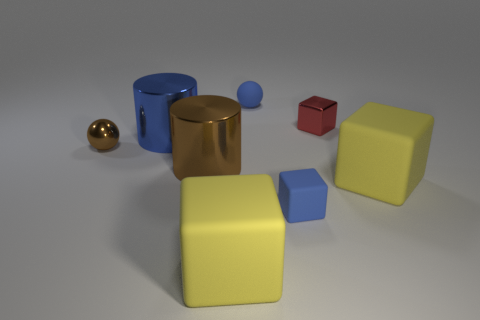Add 1 purple cubes. How many objects exist? 9 Subtract all spheres. How many objects are left? 6 Add 5 large yellow rubber cubes. How many large yellow rubber cubes are left? 7 Add 6 tiny blue cubes. How many tiny blue cubes exist? 7 Subtract 1 blue cubes. How many objects are left? 7 Subtract all small metal cubes. Subtract all cylinders. How many objects are left? 5 